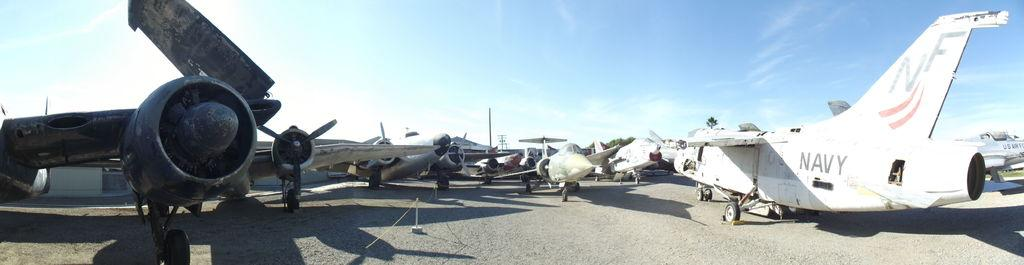<image>
Describe the image concisely. A plane with the word Navy written on its back end. 